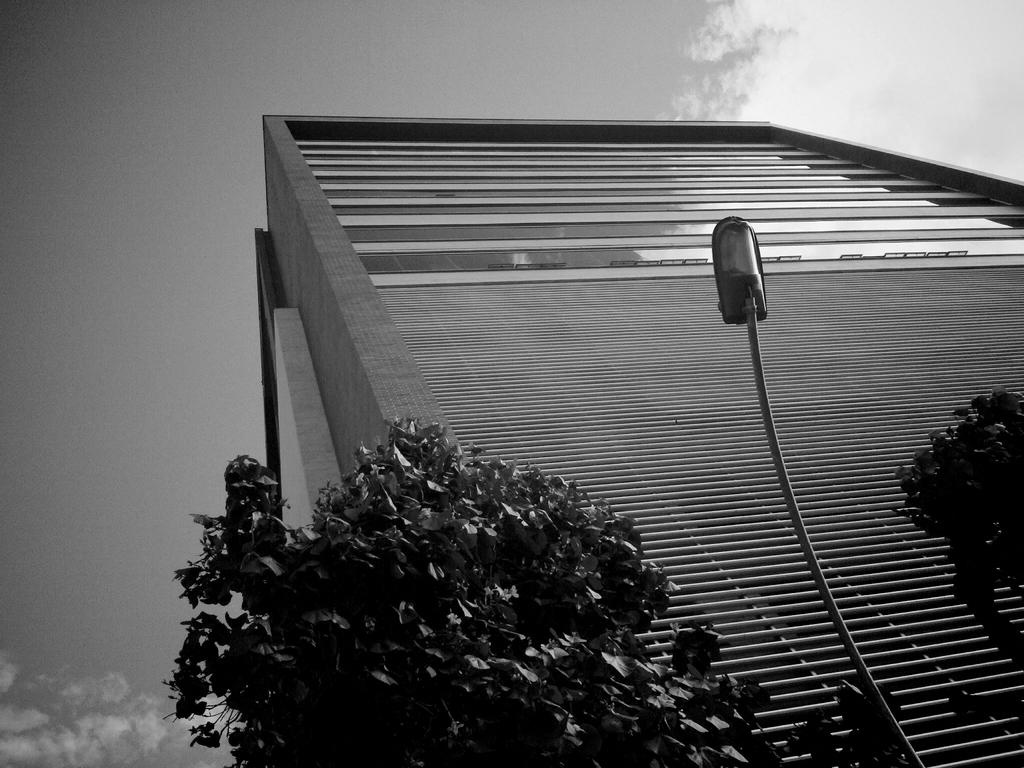What type of structure is visible in the image? There is a building in the image. What other natural elements can be seen in the image? There are trees in the image. What man-made object is present in the image? There is a street light pole in the image. What is visible in the background of the image? The sky is visible in the background of the image. What can be observed in the sky? Clouds are present in the sky. What type of cheese is being served for dinner in the image? There is no cheese or dinner present in the image. How many rabbits can be seen playing in the image? There are no rabbits present in the image. 